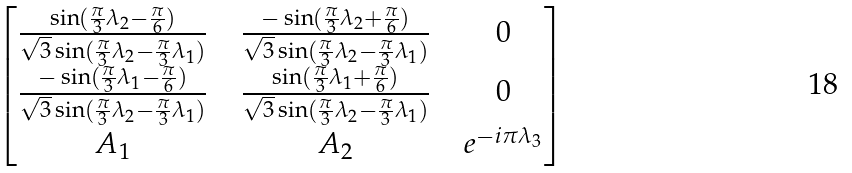<formula> <loc_0><loc_0><loc_500><loc_500>\begin{bmatrix} \frac { \sin ( \frac { \pi } { 3 } \lambda _ { 2 } - \frac { \pi } { 6 } ) } { \sqrt { 3 } \sin ( \frac { \pi } { 3 } \lambda _ { 2 } - \frac { \pi } { 3 } \lambda _ { 1 } ) } & & \frac { - \sin ( \frac { \pi } { 3 } \lambda _ { 2 } + \frac { \pi } { 6 } ) } { \sqrt { 3 } \sin ( \frac { \pi } { 3 } \lambda _ { 2 } - \frac { \pi } { 3 } \lambda _ { 1 } ) } & & 0 \\ \frac { - \sin ( \frac { \pi } { 3 } \lambda _ { 1 } - \frac { \pi } { 6 } ) } { \sqrt { 3 } \sin ( \frac { \pi } { 3 } \lambda _ { 2 } - \frac { \pi } { 3 } \lambda _ { 1 } ) } & & \frac { \sin ( \frac { \pi } { 3 } \lambda _ { 1 } + \frac { \pi } { 6 } ) } { \sqrt { 3 } \sin ( \frac { \pi } { 3 } \lambda _ { 2 } - \frac { \pi } { 3 } \lambda _ { 1 } ) } & & 0 \\ A _ { 1 } & & A _ { 2 } & & e ^ { - i \pi \lambda _ { 3 } } \end{bmatrix}</formula> 